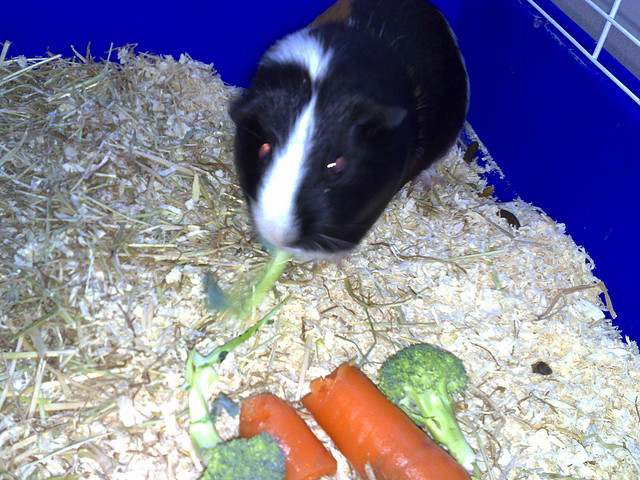Can you describe the environment the guinea pig is in? Certainly! The guinea pig is inside a habitat with a bedding of wood shavings, which are common as an absorbent bedding material for small pets. The enclosure appears to be made of plastic and there's a blue hue, perhaps from the walls of the cage or the lighting. 